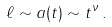<formula> <loc_0><loc_0><loc_500><loc_500>\ell \sim a ( t ) \sim t ^ { \nu } \, .</formula> 